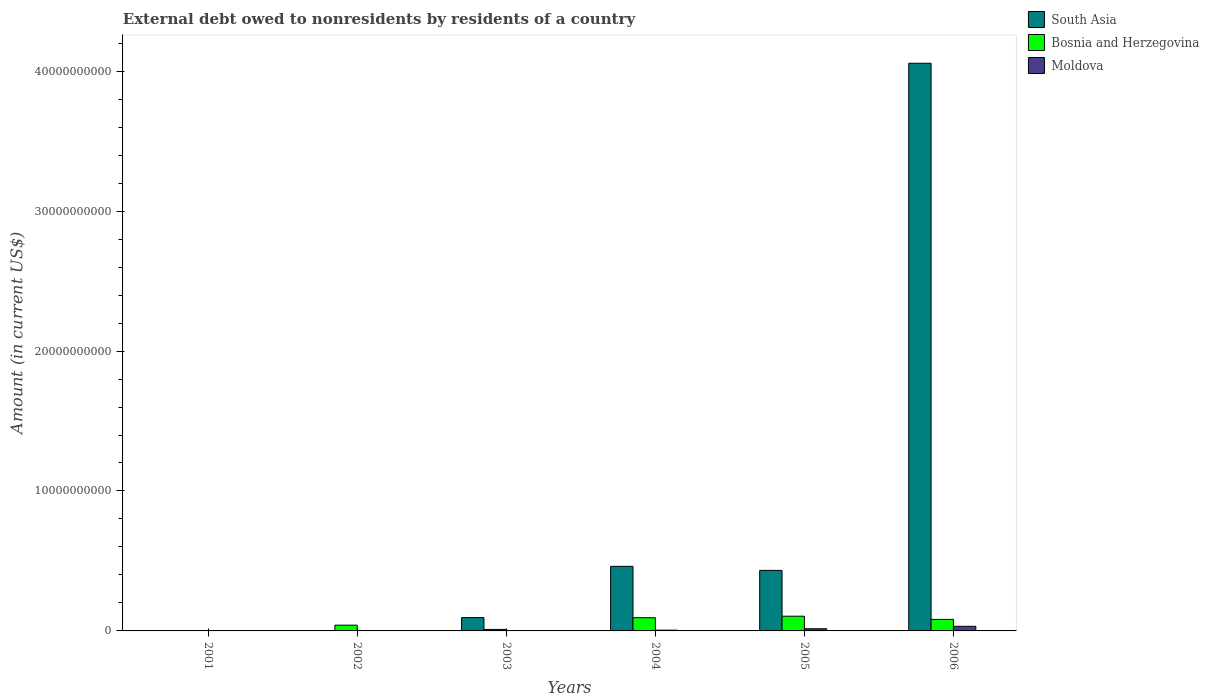How many different coloured bars are there?
Give a very brief answer. 3. How many bars are there on the 6th tick from the left?
Your answer should be compact. 3. How many bars are there on the 4th tick from the right?
Provide a succinct answer. 3. What is the label of the 5th group of bars from the left?
Give a very brief answer. 2005. In how many cases, is the number of bars for a given year not equal to the number of legend labels?
Make the answer very short. 2. Across all years, what is the maximum external debt owed by residents in Bosnia and Herzegovina?
Ensure brevity in your answer.  1.05e+09. Across all years, what is the minimum external debt owed by residents in South Asia?
Keep it short and to the point. 0. What is the total external debt owed by residents in Moldova in the graph?
Provide a succinct answer. 5.70e+08. What is the difference between the external debt owed by residents in Bosnia and Herzegovina in 2003 and that in 2006?
Your answer should be very brief. -7.17e+08. What is the difference between the external debt owed by residents in South Asia in 2003 and the external debt owed by residents in Bosnia and Herzegovina in 2004?
Keep it short and to the point. 8.16e+06. What is the average external debt owed by residents in South Asia per year?
Offer a very short reply. 8.41e+09. In the year 2004, what is the difference between the external debt owed by residents in Moldova and external debt owed by residents in Bosnia and Herzegovina?
Provide a short and direct response. -8.90e+08. In how many years, is the external debt owed by residents in Moldova greater than 28000000000 US$?
Ensure brevity in your answer.  0. What is the ratio of the external debt owed by residents in Bosnia and Herzegovina in 2003 to that in 2006?
Offer a terse response. 0.13. What is the difference between the highest and the second highest external debt owed by residents in Bosnia and Herzegovina?
Your response must be concise. 1.08e+08. What is the difference between the highest and the lowest external debt owed by residents in Moldova?
Provide a succinct answer. 3.30e+08. Is the sum of the external debt owed by residents in South Asia in 2003 and 2004 greater than the maximum external debt owed by residents in Bosnia and Herzegovina across all years?
Give a very brief answer. Yes. How many bars are there?
Keep it short and to the point. 13. Does the graph contain any zero values?
Offer a very short reply. Yes. Does the graph contain grids?
Provide a succinct answer. No. Where does the legend appear in the graph?
Offer a terse response. Top right. How many legend labels are there?
Ensure brevity in your answer.  3. What is the title of the graph?
Your answer should be compact. External debt owed to nonresidents by residents of a country. Does "Tanzania" appear as one of the legend labels in the graph?
Offer a terse response. No. What is the label or title of the X-axis?
Provide a short and direct response. Years. What is the Amount (in current US$) of Bosnia and Herzegovina in 2002?
Your answer should be very brief. 4.11e+08. What is the Amount (in current US$) of Moldova in 2002?
Your answer should be compact. 0. What is the Amount (in current US$) in South Asia in 2003?
Make the answer very short. 9.53e+08. What is the Amount (in current US$) in Bosnia and Herzegovina in 2003?
Give a very brief answer. 1.08e+08. What is the Amount (in current US$) of Moldova in 2003?
Provide a succinct answer. 2.88e+07. What is the Amount (in current US$) of South Asia in 2004?
Provide a succinct answer. 4.62e+09. What is the Amount (in current US$) of Bosnia and Herzegovina in 2004?
Give a very brief answer. 9.45e+08. What is the Amount (in current US$) of Moldova in 2004?
Your answer should be compact. 5.47e+07. What is the Amount (in current US$) of South Asia in 2005?
Keep it short and to the point. 4.33e+09. What is the Amount (in current US$) in Bosnia and Herzegovina in 2005?
Provide a succinct answer. 1.05e+09. What is the Amount (in current US$) of Moldova in 2005?
Ensure brevity in your answer.  1.57e+08. What is the Amount (in current US$) of South Asia in 2006?
Provide a short and direct response. 4.06e+1. What is the Amount (in current US$) in Bosnia and Herzegovina in 2006?
Give a very brief answer. 8.25e+08. What is the Amount (in current US$) of Moldova in 2006?
Make the answer very short. 3.30e+08. Across all years, what is the maximum Amount (in current US$) of South Asia?
Your answer should be compact. 4.06e+1. Across all years, what is the maximum Amount (in current US$) of Bosnia and Herzegovina?
Provide a succinct answer. 1.05e+09. Across all years, what is the maximum Amount (in current US$) in Moldova?
Make the answer very short. 3.30e+08. Across all years, what is the minimum Amount (in current US$) of South Asia?
Provide a succinct answer. 0. Across all years, what is the minimum Amount (in current US$) in Bosnia and Herzegovina?
Make the answer very short. 0. What is the total Amount (in current US$) of South Asia in the graph?
Your answer should be very brief. 5.05e+1. What is the total Amount (in current US$) of Bosnia and Herzegovina in the graph?
Provide a succinct answer. 3.34e+09. What is the total Amount (in current US$) of Moldova in the graph?
Ensure brevity in your answer.  5.70e+08. What is the difference between the Amount (in current US$) of Bosnia and Herzegovina in 2002 and that in 2003?
Offer a very short reply. 3.03e+08. What is the difference between the Amount (in current US$) of Bosnia and Herzegovina in 2002 and that in 2004?
Give a very brief answer. -5.33e+08. What is the difference between the Amount (in current US$) in Bosnia and Herzegovina in 2002 and that in 2005?
Your response must be concise. -6.41e+08. What is the difference between the Amount (in current US$) in Bosnia and Herzegovina in 2002 and that in 2006?
Your answer should be very brief. -4.14e+08. What is the difference between the Amount (in current US$) of South Asia in 2003 and that in 2004?
Provide a short and direct response. -3.66e+09. What is the difference between the Amount (in current US$) in Bosnia and Herzegovina in 2003 and that in 2004?
Provide a short and direct response. -8.36e+08. What is the difference between the Amount (in current US$) of Moldova in 2003 and that in 2004?
Keep it short and to the point. -2.59e+07. What is the difference between the Amount (in current US$) of South Asia in 2003 and that in 2005?
Give a very brief answer. -3.37e+09. What is the difference between the Amount (in current US$) of Bosnia and Herzegovina in 2003 and that in 2005?
Provide a short and direct response. -9.44e+08. What is the difference between the Amount (in current US$) in Moldova in 2003 and that in 2005?
Provide a succinct answer. -1.28e+08. What is the difference between the Amount (in current US$) in South Asia in 2003 and that in 2006?
Your answer should be very brief. -3.96e+1. What is the difference between the Amount (in current US$) in Bosnia and Herzegovina in 2003 and that in 2006?
Your answer should be very brief. -7.17e+08. What is the difference between the Amount (in current US$) in Moldova in 2003 and that in 2006?
Make the answer very short. -3.01e+08. What is the difference between the Amount (in current US$) in South Asia in 2004 and that in 2005?
Give a very brief answer. 2.89e+08. What is the difference between the Amount (in current US$) of Bosnia and Herzegovina in 2004 and that in 2005?
Provide a short and direct response. -1.08e+08. What is the difference between the Amount (in current US$) of Moldova in 2004 and that in 2005?
Ensure brevity in your answer.  -1.02e+08. What is the difference between the Amount (in current US$) of South Asia in 2004 and that in 2006?
Your answer should be very brief. -3.59e+1. What is the difference between the Amount (in current US$) of Bosnia and Herzegovina in 2004 and that in 2006?
Your response must be concise. 1.20e+08. What is the difference between the Amount (in current US$) in Moldova in 2004 and that in 2006?
Your answer should be compact. -2.75e+08. What is the difference between the Amount (in current US$) in South Asia in 2005 and that in 2006?
Give a very brief answer. -3.62e+1. What is the difference between the Amount (in current US$) of Bosnia and Herzegovina in 2005 and that in 2006?
Your response must be concise. 2.27e+08. What is the difference between the Amount (in current US$) in Moldova in 2005 and that in 2006?
Your answer should be very brief. -1.73e+08. What is the difference between the Amount (in current US$) in Bosnia and Herzegovina in 2002 and the Amount (in current US$) in Moldova in 2003?
Ensure brevity in your answer.  3.82e+08. What is the difference between the Amount (in current US$) of Bosnia and Herzegovina in 2002 and the Amount (in current US$) of Moldova in 2004?
Your answer should be compact. 3.57e+08. What is the difference between the Amount (in current US$) in Bosnia and Herzegovina in 2002 and the Amount (in current US$) in Moldova in 2005?
Offer a terse response. 2.54e+08. What is the difference between the Amount (in current US$) of Bosnia and Herzegovina in 2002 and the Amount (in current US$) of Moldova in 2006?
Provide a short and direct response. 8.15e+07. What is the difference between the Amount (in current US$) in South Asia in 2003 and the Amount (in current US$) in Bosnia and Herzegovina in 2004?
Offer a terse response. 8.16e+06. What is the difference between the Amount (in current US$) in South Asia in 2003 and the Amount (in current US$) in Moldova in 2004?
Your response must be concise. 8.98e+08. What is the difference between the Amount (in current US$) of Bosnia and Herzegovina in 2003 and the Amount (in current US$) of Moldova in 2004?
Offer a very short reply. 5.34e+07. What is the difference between the Amount (in current US$) of South Asia in 2003 and the Amount (in current US$) of Bosnia and Herzegovina in 2005?
Give a very brief answer. -9.95e+07. What is the difference between the Amount (in current US$) in South Asia in 2003 and the Amount (in current US$) in Moldova in 2005?
Offer a very short reply. 7.96e+08. What is the difference between the Amount (in current US$) of Bosnia and Herzegovina in 2003 and the Amount (in current US$) of Moldova in 2005?
Keep it short and to the point. -4.89e+07. What is the difference between the Amount (in current US$) of South Asia in 2003 and the Amount (in current US$) of Bosnia and Herzegovina in 2006?
Your answer should be very brief. 1.28e+08. What is the difference between the Amount (in current US$) of South Asia in 2003 and the Amount (in current US$) of Moldova in 2006?
Make the answer very short. 6.23e+08. What is the difference between the Amount (in current US$) in Bosnia and Herzegovina in 2003 and the Amount (in current US$) in Moldova in 2006?
Ensure brevity in your answer.  -2.22e+08. What is the difference between the Amount (in current US$) of South Asia in 2004 and the Amount (in current US$) of Bosnia and Herzegovina in 2005?
Your answer should be compact. 3.56e+09. What is the difference between the Amount (in current US$) of South Asia in 2004 and the Amount (in current US$) of Moldova in 2005?
Keep it short and to the point. 4.46e+09. What is the difference between the Amount (in current US$) in Bosnia and Herzegovina in 2004 and the Amount (in current US$) in Moldova in 2005?
Your response must be concise. 7.88e+08. What is the difference between the Amount (in current US$) in South Asia in 2004 and the Amount (in current US$) in Bosnia and Herzegovina in 2006?
Give a very brief answer. 3.79e+09. What is the difference between the Amount (in current US$) of South Asia in 2004 and the Amount (in current US$) of Moldova in 2006?
Give a very brief answer. 4.29e+09. What is the difference between the Amount (in current US$) in Bosnia and Herzegovina in 2004 and the Amount (in current US$) in Moldova in 2006?
Ensure brevity in your answer.  6.15e+08. What is the difference between the Amount (in current US$) of South Asia in 2005 and the Amount (in current US$) of Bosnia and Herzegovina in 2006?
Provide a succinct answer. 3.50e+09. What is the difference between the Amount (in current US$) of South Asia in 2005 and the Amount (in current US$) of Moldova in 2006?
Offer a very short reply. 4.00e+09. What is the difference between the Amount (in current US$) of Bosnia and Herzegovina in 2005 and the Amount (in current US$) of Moldova in 2006?
Provide a short and direct response. 7.22e+08. What is the average Amount (in current US$) of South Asia per year?
Offer a very short reply. 8.41e+09. What is the average Amount (in current US$) in Bosnia and Herzegovina per year?
Keep it short and to the point. 5.57e+08. What is the average Amount (in current US$) in Moldova per year?
Make the answer very short. 9.50e+07. In the year 2003, what is the difference between the Amount (in current US$) of South Asia and Amount (in current US$) of Bosnia and Herzegovina?
Offer a terse response. 8.45e+08. In the year 2003, what is the difference between the Amount (in current US$) in South Asia and Amount (in current US$) in Moldova?
Provide a succinct answer. 9.24e+08. In the year 2003, what is the difference between the Amount (in current US$) of Bosnia and Herzegovina and Amount (in current US$) of Moldova?
Offer a terse response. 7.93e+07. In the year 2004, what is the difference between the Amount (in current US$) of South Asia and Amount (in current US$) of Bosnia and Herzegovina?
Provide a short and direct response. 3.67e+09. In the year 2004, what is the difference between the Amount (in current US$) of South Asia and Amount (in current US$) of Moldova?
Your answer should be compact. 4.56e+09. In the year 2004, what is the difference between the Amount (in current US$) in Bosnia and Herzegovina and Amount (in current US$) in Moldova?
Your response must be concise. 8.90e+08. In the year 2005, what is the difference between the Amount (in current US$) of South Asia and Amount (in current US$) of Bosnia and Herzegovina?
Your response must be concise. 3.27e+09. In the year 2005, what is the difference between the Amount (in current US$) of South Asia and Amount (in current US$) of Moldova?
Give a very brief answer. 4.17e+09. In the year 2005, what is the difference between the Amount (in current US$) in Bosnia and Herzegovina and Amount (in current US$) in Moldova?
Keep it short and to the point. 8.95e+08. In the year 2006, what is the difference between the Amount (in current US$) in South Asia and Amount (in current US$) in Bosnia and Herzegovina?
Offer a terse response. 3.97e+1. In the year 2006, what is the difference between the Amount (in current US$) of South Asia and Amount (in current US$) of Moldova?
Offer a very short reply. 4.02e+1. In the year 2006, what is the difference between the Amount (in current US$) of Bosnia and Herzegovina and Amount (in current US$) of Moldova?
Make the answer very short. 4.95e+08. What is the ratio of the Amount (in current US$) of Bosnia and Herzegovina in 2002 to that in 2003?
Keep it short and to the point. 3.8. What is the ratio of the Amount (in current US$) in Bosnia and Herzegovina in 2002 to that in 2004?
Offer a terse response. 0.44. What is the ratio of the Amount (in current US$) of Bosnia and Herzegovina in 2002 to that in 2005?
Provide a succinct answer. 0.39. What is the ratio of the Amount (in current US$) of Bosnia and Herzegovina in 2002 to that in 2006?
Your response must be concise. 0.5. What is the ratio of the Amount (in current US$) of South Asia in 2003 to that in 2004?
Give a very brief answer. 0.21. What is the ratio of the Amount (in current US$) of Bosnia and Herzegovina in 2003 to that in 2004?
Make the answer very short. 0.11. What is the ratio of the Amount (in current US$) of Moldova in 2003 to that in 2004?
Ensure brevity in your answer.  0.53. What is the ratio of the Amount (in current US$) of South Asia in 2003 to that in 2005?
Give a very brief answer. 0.22. What is the ratio of the Amount (in current US$) in Bosnia and Herzegovina in 2003 to that in 2005?
Make the answer very short. 0.1. What is the ratio of the Amount (in current US$) of Moldova in 2003 to that in 2005?
Offer a terse response. 0.18. What is the ratio of the Amount (in current US$) of South Asia in 2003 to that in 2006?
Keep it short and to the point. 0.02. What is the ratio of the Amount (in current US$) of Bosnia and Herzegovina in 2003 to that in 2006?
Your answer should be compact. 0.13. What is the ratio of the Amount (in current US$) of Moldova in 2003 to that in 2006?
Your response must be concise. 0.09. What is the ratio of the Amount (in current US$) in South Asia in 2004 to that in 2005?
Keep it short and to the point. 1.07. What is the ratio of the Amount (in current US$) of Bosnia and Herzegovina in 2004 to that in 2005?
Ensure brevity in your answer.  0.9. What is the ratio of the Amount (in current US$) of Moldova in 2004 to that in 2005?
Your response must be concise. 0.35. What is the ratio of the Amount (in current US$) of South Asia in 2004 to that in 2006?
Your answer should be very brief. 0.11. What is the ratio of the Amount (in current US$) of Bosnia and Herzegovina in 2004 to that in 2006?
Give a very brief answer. 1.15. What is the ratio of the Amount (in current US$) of Moldova in 2004 to that in 2006?
Offer a very short reply. 0.17. What is the ratio of the Amount (in current US$) in South Asia in 2005 to that in 2006?
Your response must be concise. 0.11. What is the ratio of the Amount (in current US$) of Bosnia and Herzegovina in 2005 to that in 2006?
Provide a succinct answer. 1.28. What is the ratio of the Amount (in current US$) of Moldova in 2005 to that in 2006?
Give a very brief answer. 0.48. What is the difference between the highest and the second highest Amount (in current US$) of South Asia?
Provide a short and direct response. 3.59e+1. What is the difference between the highest and the second highest Amount (in current US$) of Bosnia and Herzegovina?
Provide a succinct answer. 1.08e+08. What is the difference between the highest and the second highest Amount (in current US$) of Moldova?
Make the answer very short. 1.73e+08. What is the difference between the highest and the lowest Amount (in current US$) of South Asia?
Provide a succinct answer. 4.06e+1. What is the difference between the highest and the lowest Amount (in current US$) in Bosnia and Herzegovina?
Keep it short and to the point. 1.05e+09. What is the difference between the highest and the lowest Amount (in current US$) of Moldova?
Keep it short and to the point. 3.30e+08. 